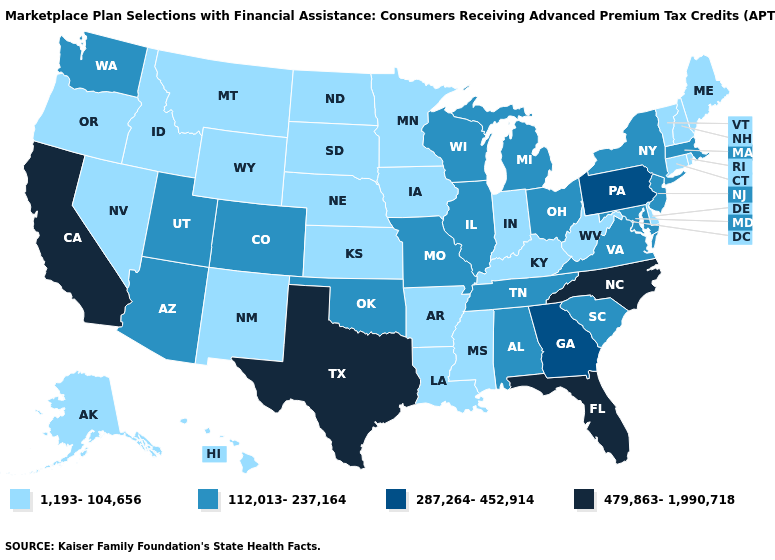Does California have a lower value than Ohio?
Answer briefly. No. Name the states that have a value in the range 479,863-1,990,718?
Keep it brief. California, Florida, North Carolina, Texas. How many symbols are there in the legend?
Quick response, please. 4. Name the states that have a value in the range 287,264-452,914?
Quick response, please. Georgia, Pennsylvania. Among the states that border Virginia , does Kentucky have the highest value?
Keep it brief. No. Which states hav the highest value in the West?
Give a very brief answer. California. Which states hav the highest value in the South?
Keep it brief. Florida, North Carolina, Texas. Name the states that have a value in the range 112,013-237,164?
Write a very short answer. Alabama, Arizona, Colorado, Illinois, Maryland, Massachusetts, Michigan, Missouri, New Jersey, New York, Ohio, Oklahoma, South Carolina, Tennessee, Utah, Virginia, Washington, Wisconsin. Which states have the lowest value in the West?
Answer briefly. Alaska, Hawaii, Idaho, Montana, Nevada, New Mexico, Oregon, Wyoming. What is the highest value in states that border Arkansas?
Answer briefly. 479,863-1,990,718. Name the states that have a value in the range 287,264-452,914?
Short answer required. Georgia, Pennsylvania. What is the value of New York?
Be succinct. 112,013-237,164. Which states hav the highest value in the Northeast?
Be succinct. Pennsylvania. Which states have the lowest value in the MidWest?
Concise answer only. Indiana, Iowa, Kansas, Minnesota, Nebraska, North Dakota, South Dakota. Name the states that have a value in the range 1,193-104,656?
Keep it brief. Alaska, Arkansas, Connecticut, Delaware, Hawaii, Idaho, Indiana, Iowa, Kansas, Kentucky, Louisiana, Maine, Minnesota, Mississippi, Montana, Nebraska, Nevada, New Hampshire, New Mexico, North Dakota, Oregon, Rhode Island, South Dakota, Vermont, West Virginia, Wyoming. 